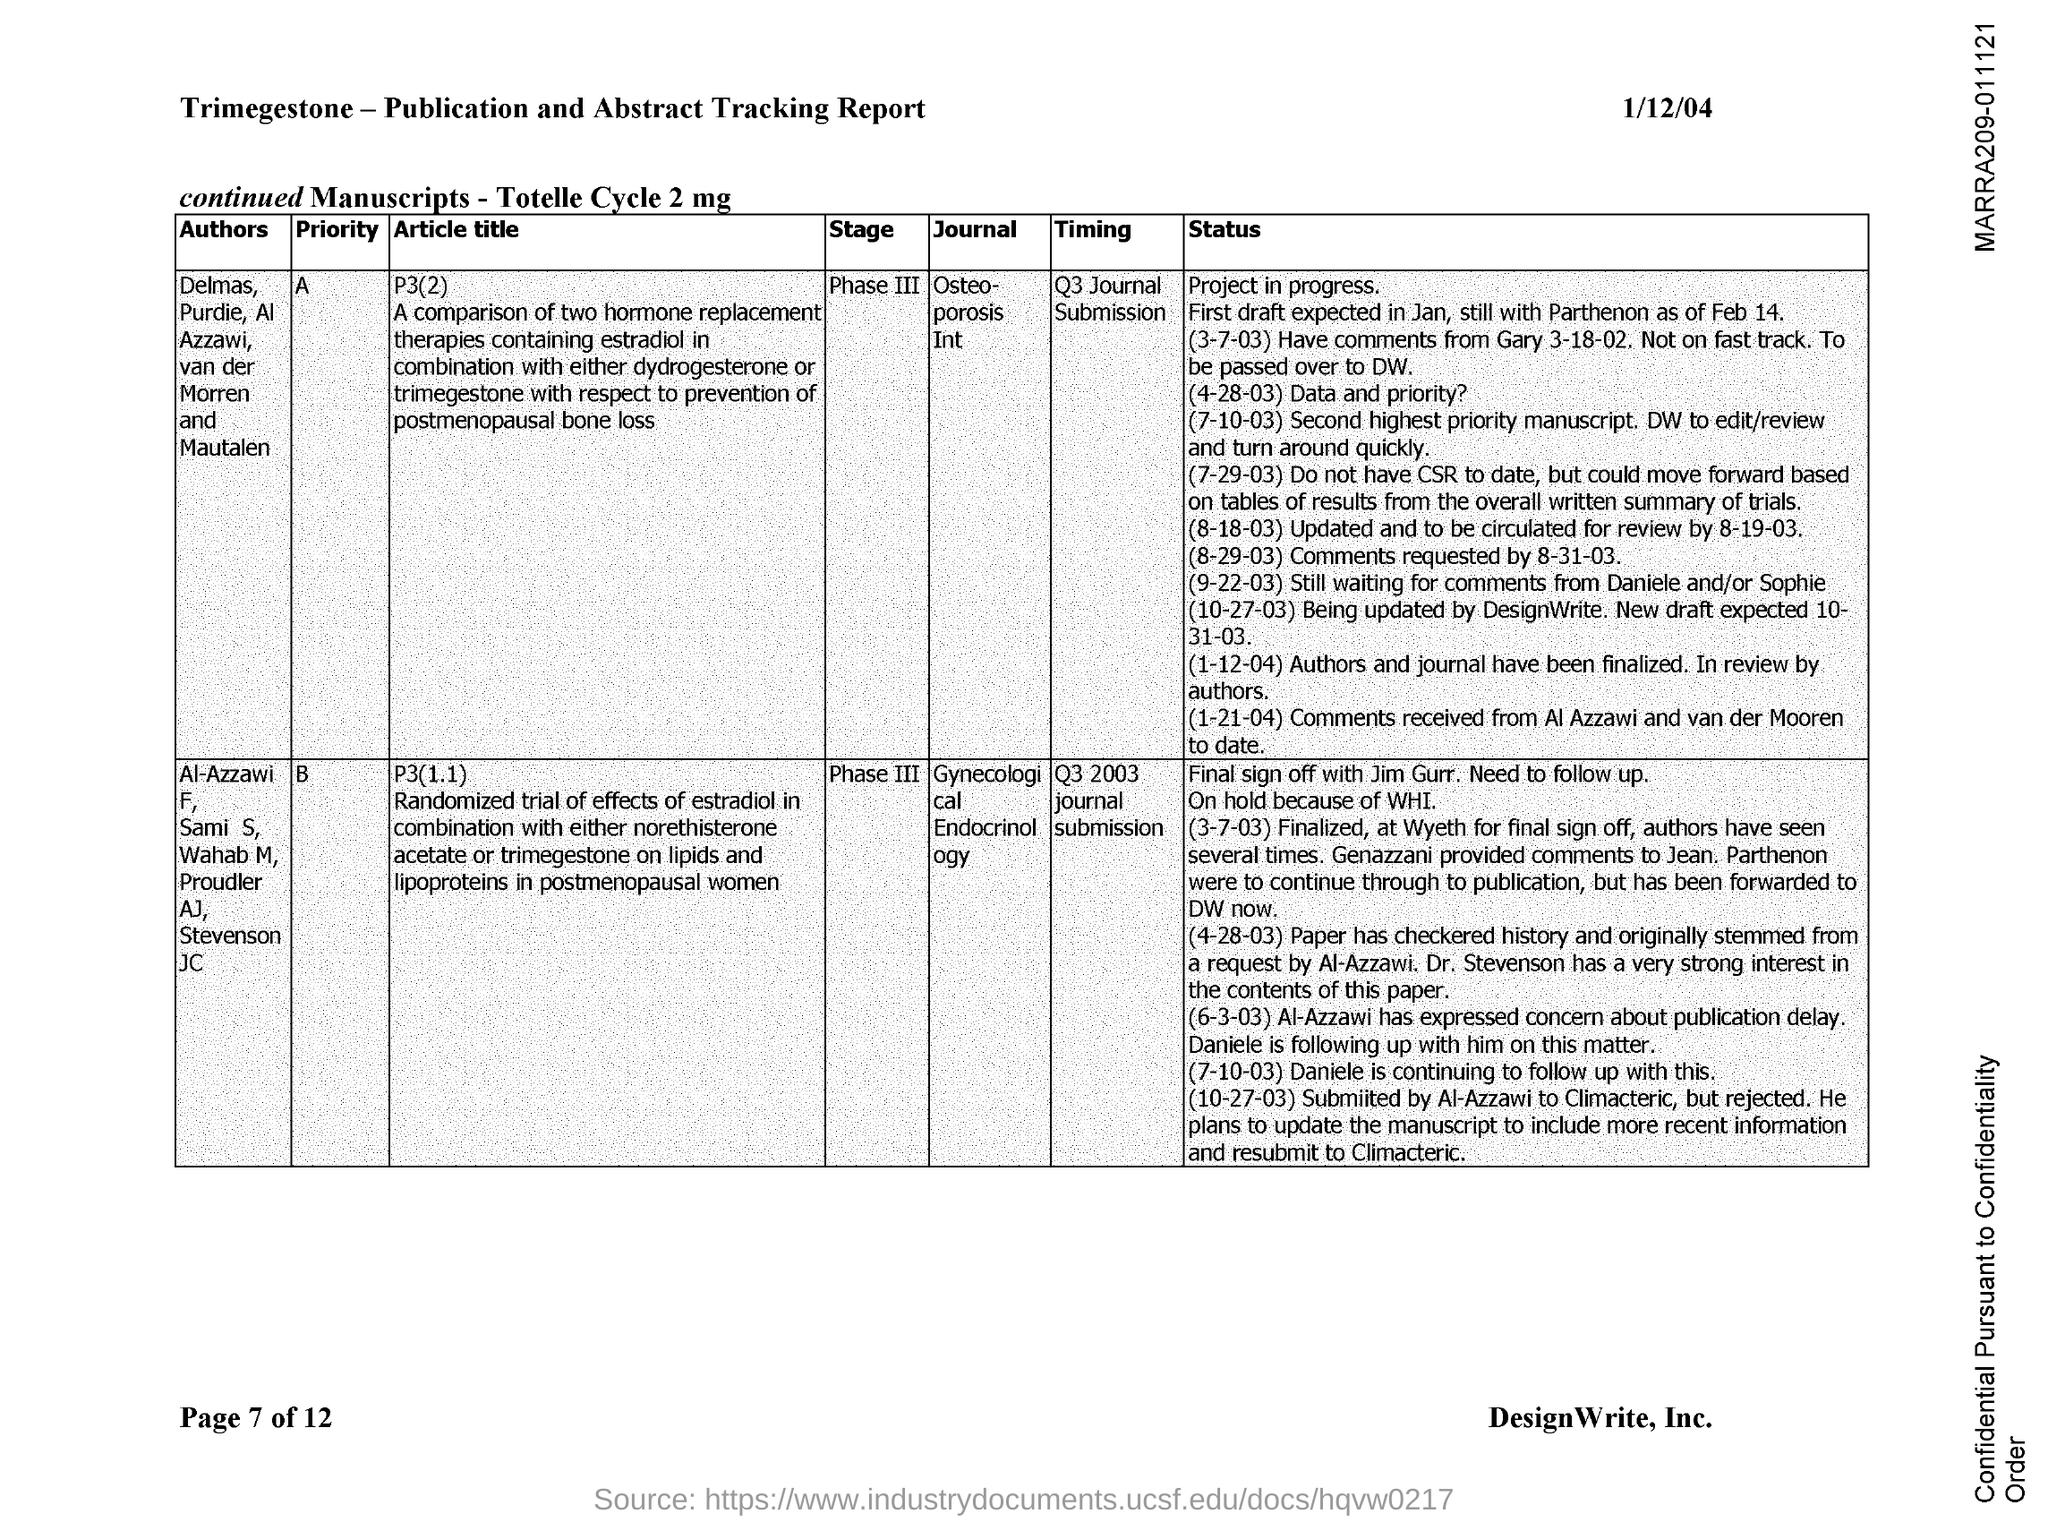Indicate a few pertinent items in this graphic. The date mentioned in the document is 1/12/04. The current stage of the journal with priority "B" is Phase III. The current stage of the journal with priority "A" is Phase III. The journal with the highest priority is called "Osteoporosis Int. The journal with priority "B" is called Gynecological Endocrinology. 